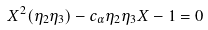<formula> <loc_0><loc_0><loc_500><loc_500>X ^ { 2 } ( \eta _ { 2 } \eta _ { 3 } ) - c _ { \alpha } \eta _ { 2 } \eta _ { 3 } X - 1 = 0</formula> 